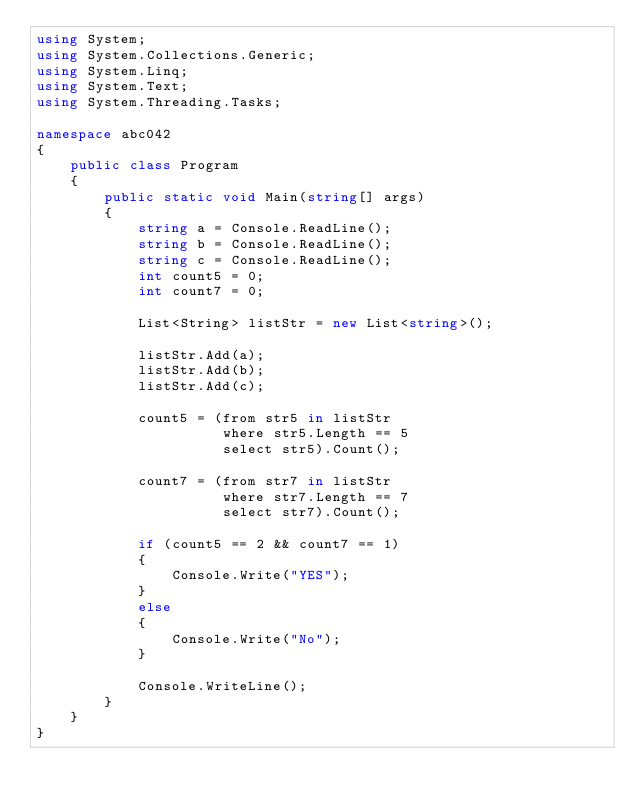Convert code to text. <code><loc_0><loc_0><loc_500><loc_500><_C#_>using System;
using System.Collections.Generic;
using System.Linq;
using System.Text;
using System.Threading.Tasks;

namespace abc042
{
    public class Program
    {
        public static void Main(string[] args)
        {
            string a = Console.ReadLine();
            string b = Console.ReadLine();
            string c = Console.ReadLine();
            int count5 = 0;
            int count7 = 0;

            List<String> listStr = new List<string>();

            listStr.Add(a);
            listStr.Add(b);
            listStr.Add(c);

            count5 = (from str5 in listStr
                      where str5.Length == 5
                      select str5).Count();

            count7 = (from str7 in listStr
                      where str7.Length == 7
                      select str7).Count();

            if (count5 == 2 && count7 == 1)
            {
                Console.Write("YES");
            }
            else
            {
                Console.Write("No");
            }

            Console.WriteLine();
        }
    }
}
</code> 